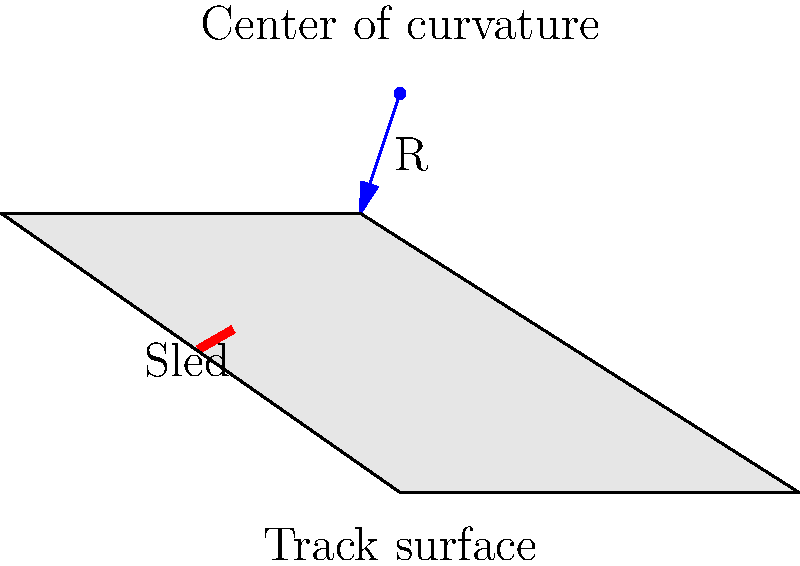In the cross-sectional view of a luge track turn shown above, what factor primarily determines the optimal radius of curvature (R) for the track design, and how does it relate to the maximum speed of the luge? To determine the optimal radius of curvature for a luge track turn, we need to consider several factors:

1. Centripetal force: As the luge moves through the turn, it experiences a centripetal force that keeps it on the curved path. This force is given by the equation:

   $$F_c = \frac{mv^2}{R}$$

   where $m$ is the mass of the luge and rider, $v$ is the velocity, and $R$ is the radius of curvature.

2. Normal force: The normal force from the track surface must provide this centripetal force. The maximum normal force is limited by the weight of the luge and rider, plus any additional force from the banked angle of the track.

3. Maximum speed: The maximum speed that can be safely maintained through the turn is related to the radius of curvature. We can derive this relationship by equating the centripetal force to the maximum normal force:

   $$\frac{mv^2}{R} = N_{max}$$

   Solving for $v$:

   $$v_{max} = \sqrt{\frac{R \cdot N_{max}}{m}}$$

4. Optimal radius: The optimal radius of curvature is a balance between allowing high speeds (larger radius) and creating a compact, challenging track (smaller radius). It must also consider the g-forces experienced by the athlete, which should not exceed safe limits.

5. Relationship to maximum speed: From the equation above, we can see that the maximum speed is proportional to the square root of the radius of curvature:

   $$v_{max} \propto \sqrt{R}$$

This means that increasing the radius of curvature allows for higher maximum speeds through the turn, but with diminishing returns as the radius increases.

In practical track design, the optimal radius is chosen to allow for exciting speeds while maintaining safety and fitting within the available space for the track construction.
Answer: The optimal radius of curvature is primarily determined by the desired maximum speed, with $v_{max} \propto \sqrt{R}$. 